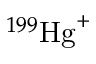Convert formula to latex. <formula><loc_0><loc_0><loc_500><loc_500>^ { 1 9 9 } { H g } ^ { + }</formula> 